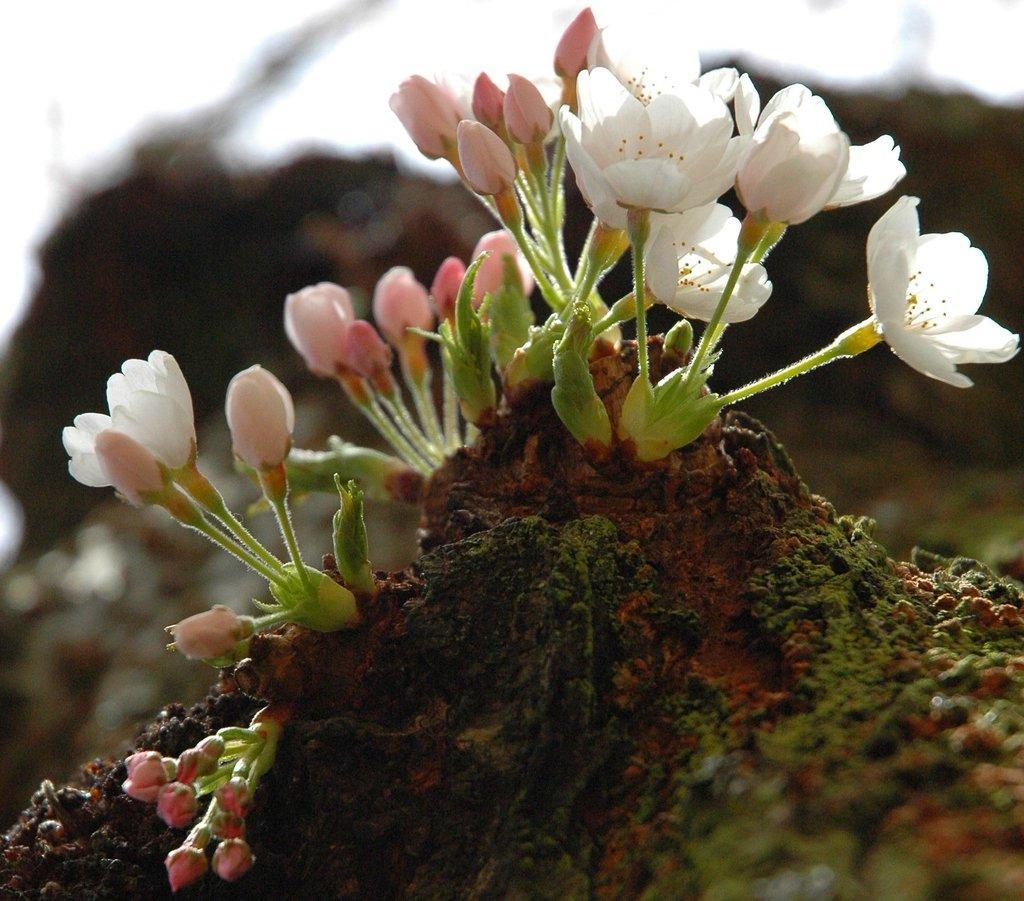Could you give a brief overview of what you see in this image? In this picture I can observe white and pink color flowers on the ground. On the left side I can observe pink color flower buds. The background is completely blurred. 